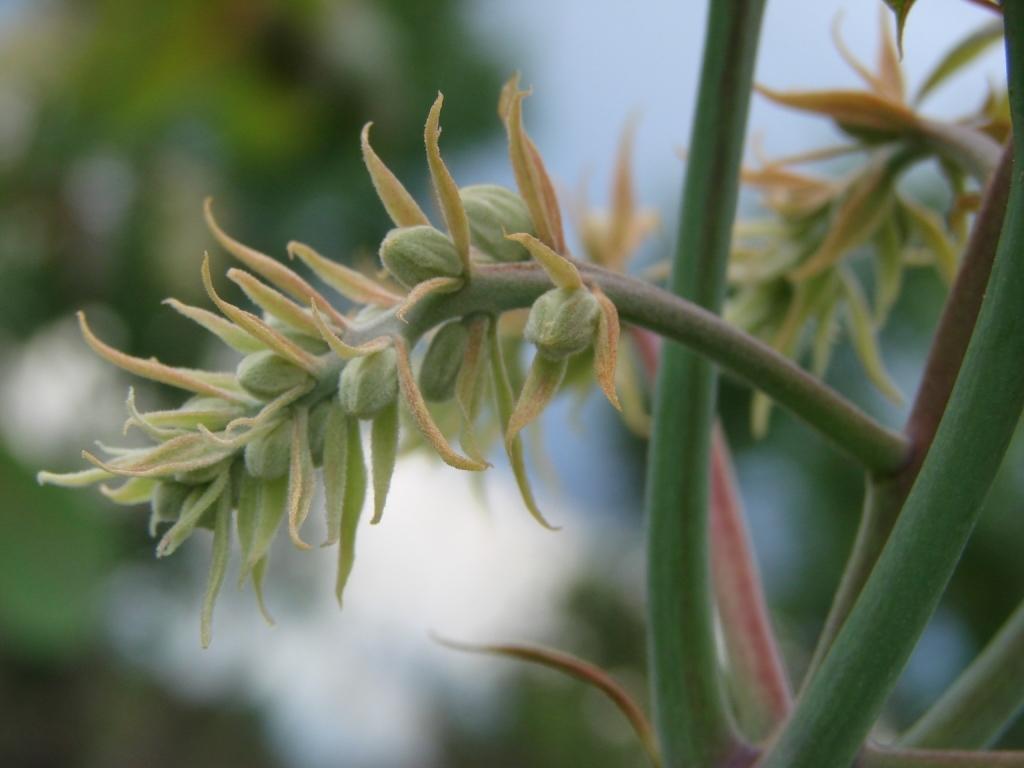Please provide a concise description of this image. In this picture we can see plants and in the background we can see leaves and it is blurry. 